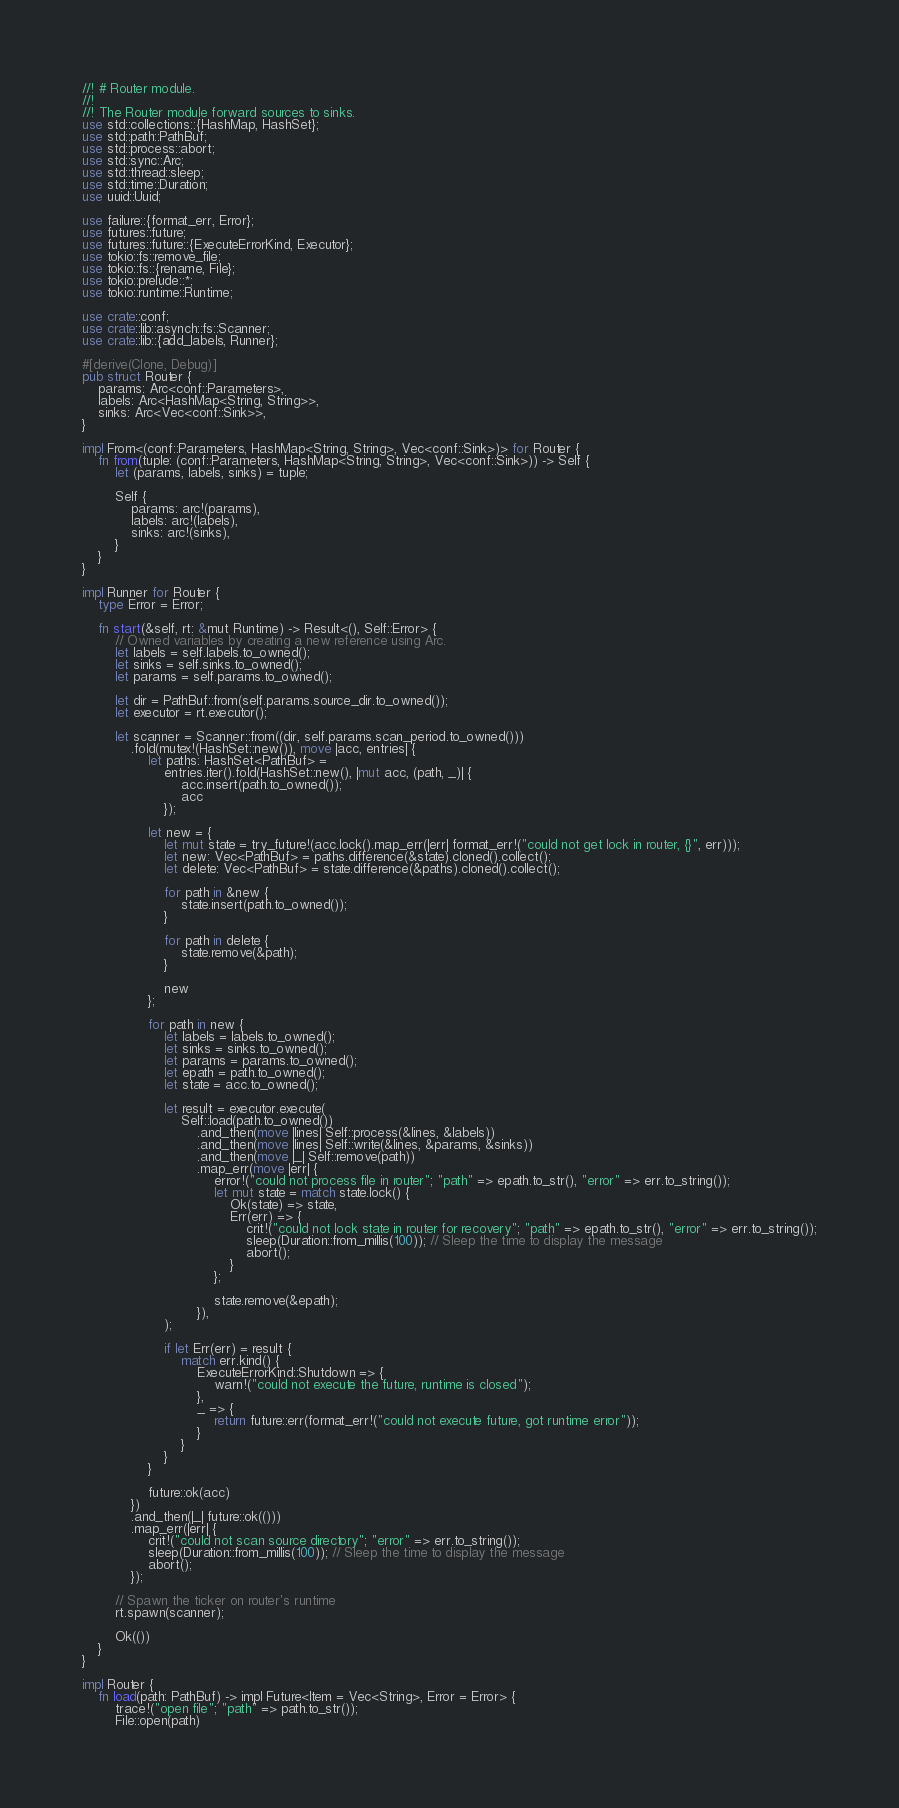<code> <loc_0><loc_0><loc_500><loc_500><_Rust_>//! # Router module.
//!
//! The Router module forward sources to sinks.
use std::collections::{HashMap, HashSet};
use std::path::PathBuf;
use std::process::abort;
use std::sync::Arc;
use std::thread::sleep;
use std::time::Duration;
use uuid::Uuid;

use failure::{format_err, Error};
use futures::future;
use futures::future::{ExecuteErrorKind, Executor};
use tokio::fs::remove_file;
use tokio::fs::{rename, File};
use tokio::prelude::*;
use tokio::runtime::Runtime;

use crate::conf;
use crate::lib::asynch::fs::Scanner;
use crate::lib::{add_labels, Runner};

#[derive(Clone, Debug)]
pub struct Router {
    params: Arc<conf::Parameters>,
    labels: Arc<HashMap<String, String>>,
    sinks: Arc<Vec<conf::Sink>>,
}

impl From<(conf::Parameters, HashMap<String, String>, Vec<conf::Sink>)> for Router {
    fn from(tuple: (conf::Parameters, HashMap<String, String>, Vec<conf::Sink>)) -> Self {
        let (params, labels, sinks) = tuple;

        Self {
            params: arc!(params),
            labels: arc!(labels),
            sinks: arc!(sinks),
        }
    }
}

impl Runner for Router {
    type Error = Error;

    fn start(&self, rt: &mut Runtime) -> Result<(), Self::Error> {
        // Owned variables by creating a new reference using Arc.
        let labels = self.labels.to_owned();
        let sinks = self.sinks.to_owned();
        let params = self.params.to_owned();

        let dir = PathBuf::from(self.params.source_dir.to_owned());
        let executor = rt.executor();

        let scanner = Scanner::from((dir, self.params.scan_period.to_owned()))
            .fold(mutex!(HashSet::new()), move |acc, entries| {
                let paths: HashSet<PathBuf> =
                    entries.iter().fold(HashSet::new(), |mut acc, (path, _)| {
                        acc.insert(path.to_owned());
                        acc
                    });

                let new = {
                    let mut state = try_future!(acc.lock().map_err(|err| format_err!("could not get lock in router, {}", err)));
                    let new: Vec<PathBuf> = paths.difference(&state).cloned().collect();
                    let delete: Vec<PathBuf> = state.difference(&paths).cloned().collect();

                    for path in &new {
                        state.insert(path.to_owned());
                    }

                    for path in delete {
                        state.remove(&path);
                    }

                    new
                };

                for path in new {
                    let labels = labels.to_owned();
                    let sinks = sinks.to_owned();
                    let params = params.to_owned();
                    let epath = path.to_owned();
                    let state = acc.to_owned();

                    let result = executor.execute(
                        Self::load(path.to_owned())
                            .and_then(move |lines| Self::process(&lines, &labels))
                            .and_then(move |lines| Self::write(&lines, &params, &sinks))
                            .and_then(move |_| Self::remove(path))
                            .map_err(move |err| {
                                error!("could not process file in router"; "path" => epath.to_str(), "error" => err.to_string());
                                let mut state = match state.lock() {
                                    Ok(state) => state,
                                    Err(err) => {
                                        crit!("could not lock state in router for recovery"; "path" => epath.to_str(), "error" => err.to_string());
                                        sleep(Duration::from_millis(100)); // Sleep the time to display the message
                                        abort();
                                    }
                                };

                                state.remove(&epath);
                            }),
                    );

                    if let Err(err) = result {
                        match err.kind() {
                            ExecuteErrorKind::Shutdown => {
                                warn!("could not execute the future, runtime is closed");
                            },
                            _ => {
                                return future::err(format_err!("could not execute future, got runtime error"));
                            }
                        }
                    }
                }

                future::ok(acc)
            })
            .and_then(|_| future::ok(()))
            .map_err(|err| {
                crit!("could not scan source directory"; "error" => err.to_string());
                sleep(Duration::from_millis(100)); // Sleep the time to display the message
                abort();
            });

        // Spawn the ticker on router's runtime
        rt.spawn(scanner);

        Ok(())
    }
}

impl Router {
    fn load(path: PathBuf) -> impl Future<Item = Vec<String>, Error = Error> {
        trace!("open file"; "path" => path.to_str());
        File::open(path)</code> 